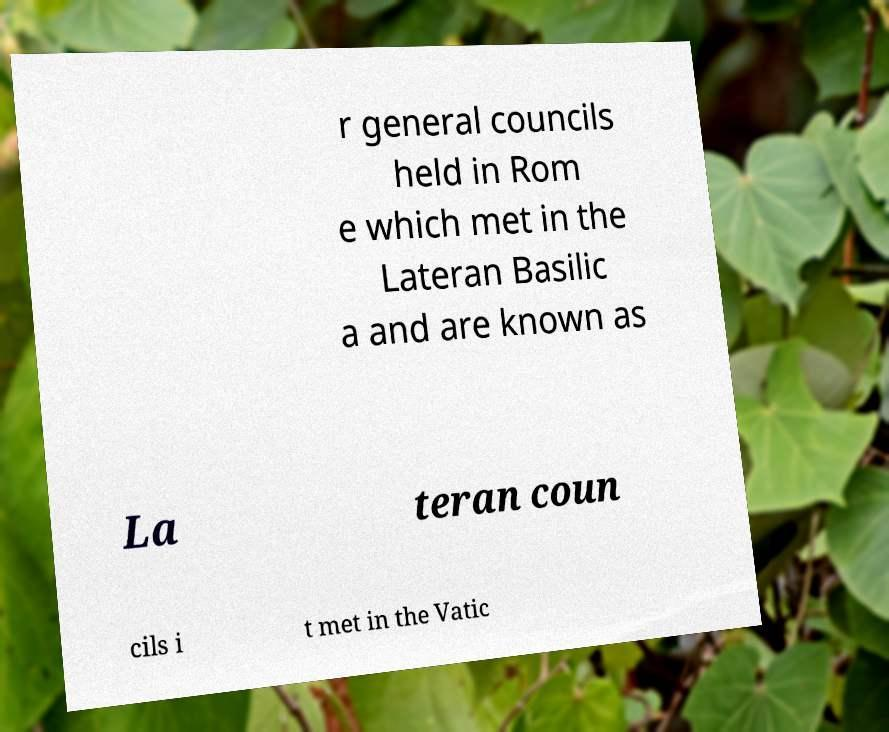For documentation purposes, I need the text within this image transcribed. Could you provide that? r general councils held in Rom e which met in the Lateran Basilic a and are known as La teran coun cils i t met in the Vatic 